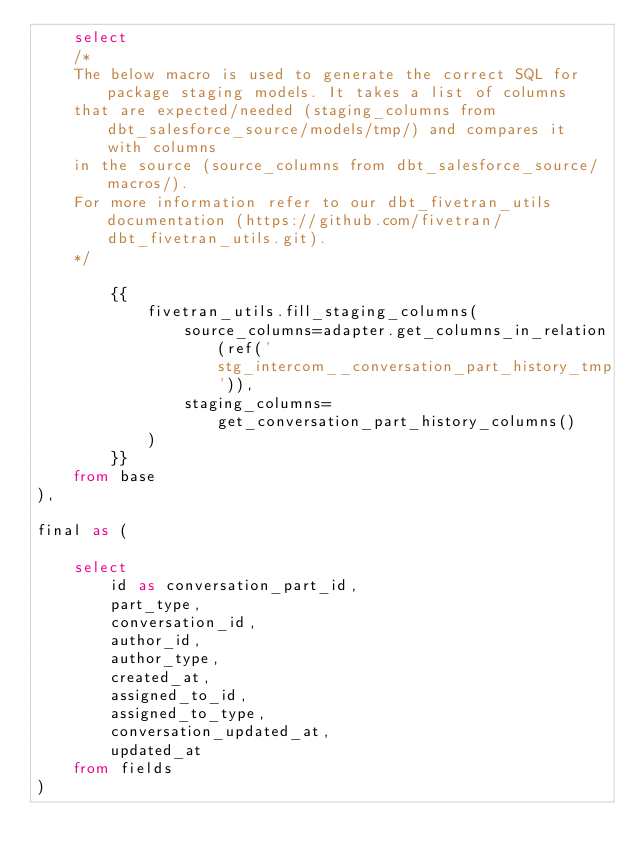Convert code to text. <code><loc_0><loc_0><loc_500><loc_500><_SQL_>    select
    /*
    The below macro is used to generate the correct SQL for package staging models. It takes a list of columns 
    that are expected/needed (staging_columns from dbt_salesforce_source/models/tmp/) and compares it with columns 
    in the source (source_columns from dbt_salesforce_source/macros/).
    For more information refer to our dbt_fivetran_utils documentation (https://github.com/fivetran/dbt_fivetran_utils.git).
    */

        {{
            fivetran_utils.fill_staging_columns(
                source_columns=adapter.get_columns_in_relation(ref('stg_intercom__conversation_part_history_tmp')),
                staging_columns=get_conversation_part_history_columns()
            )
        }}       
    from base
),

final as (
    
    select 
        id as conversation_part_id,
        part_type,
        conversation_id,
        author_id,
        author_type,
        created_at,
        assigned_to_id,
        assigned_to_type,
        conversation_updated_at,
        updated_at
    from fields
)
</code> 